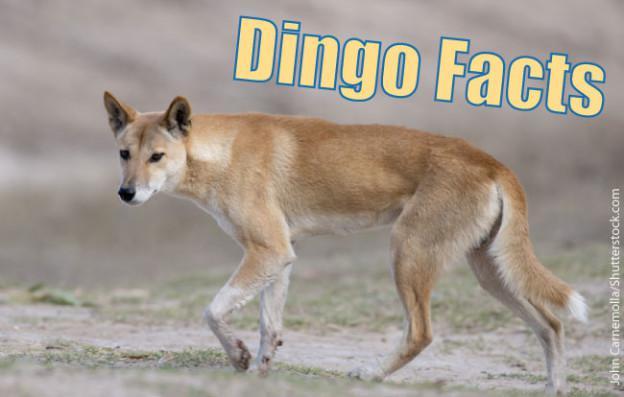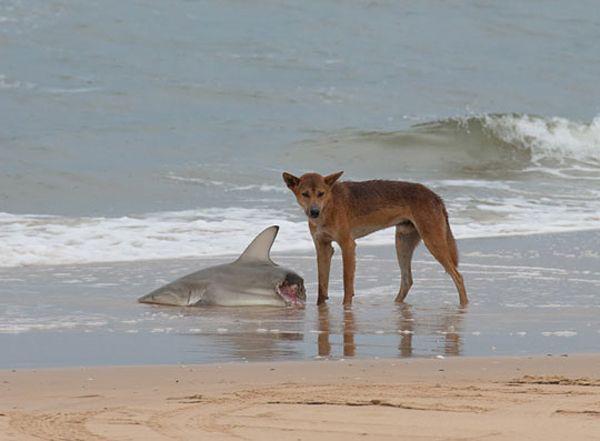The first image is the image on the left, the second image is the image on the right. For the images displayed, is the sentence "A dog is at the left of an image, standing behind a dead animal washed up on a beach." factually correct? Answer yes or no. No. The first image is the image on the left, the second image is the image on the right. Examine the images to the left and right. Is the description "The dingo's body in the left image is facing towards the left." accurate? Answer yes or no. Yes. 